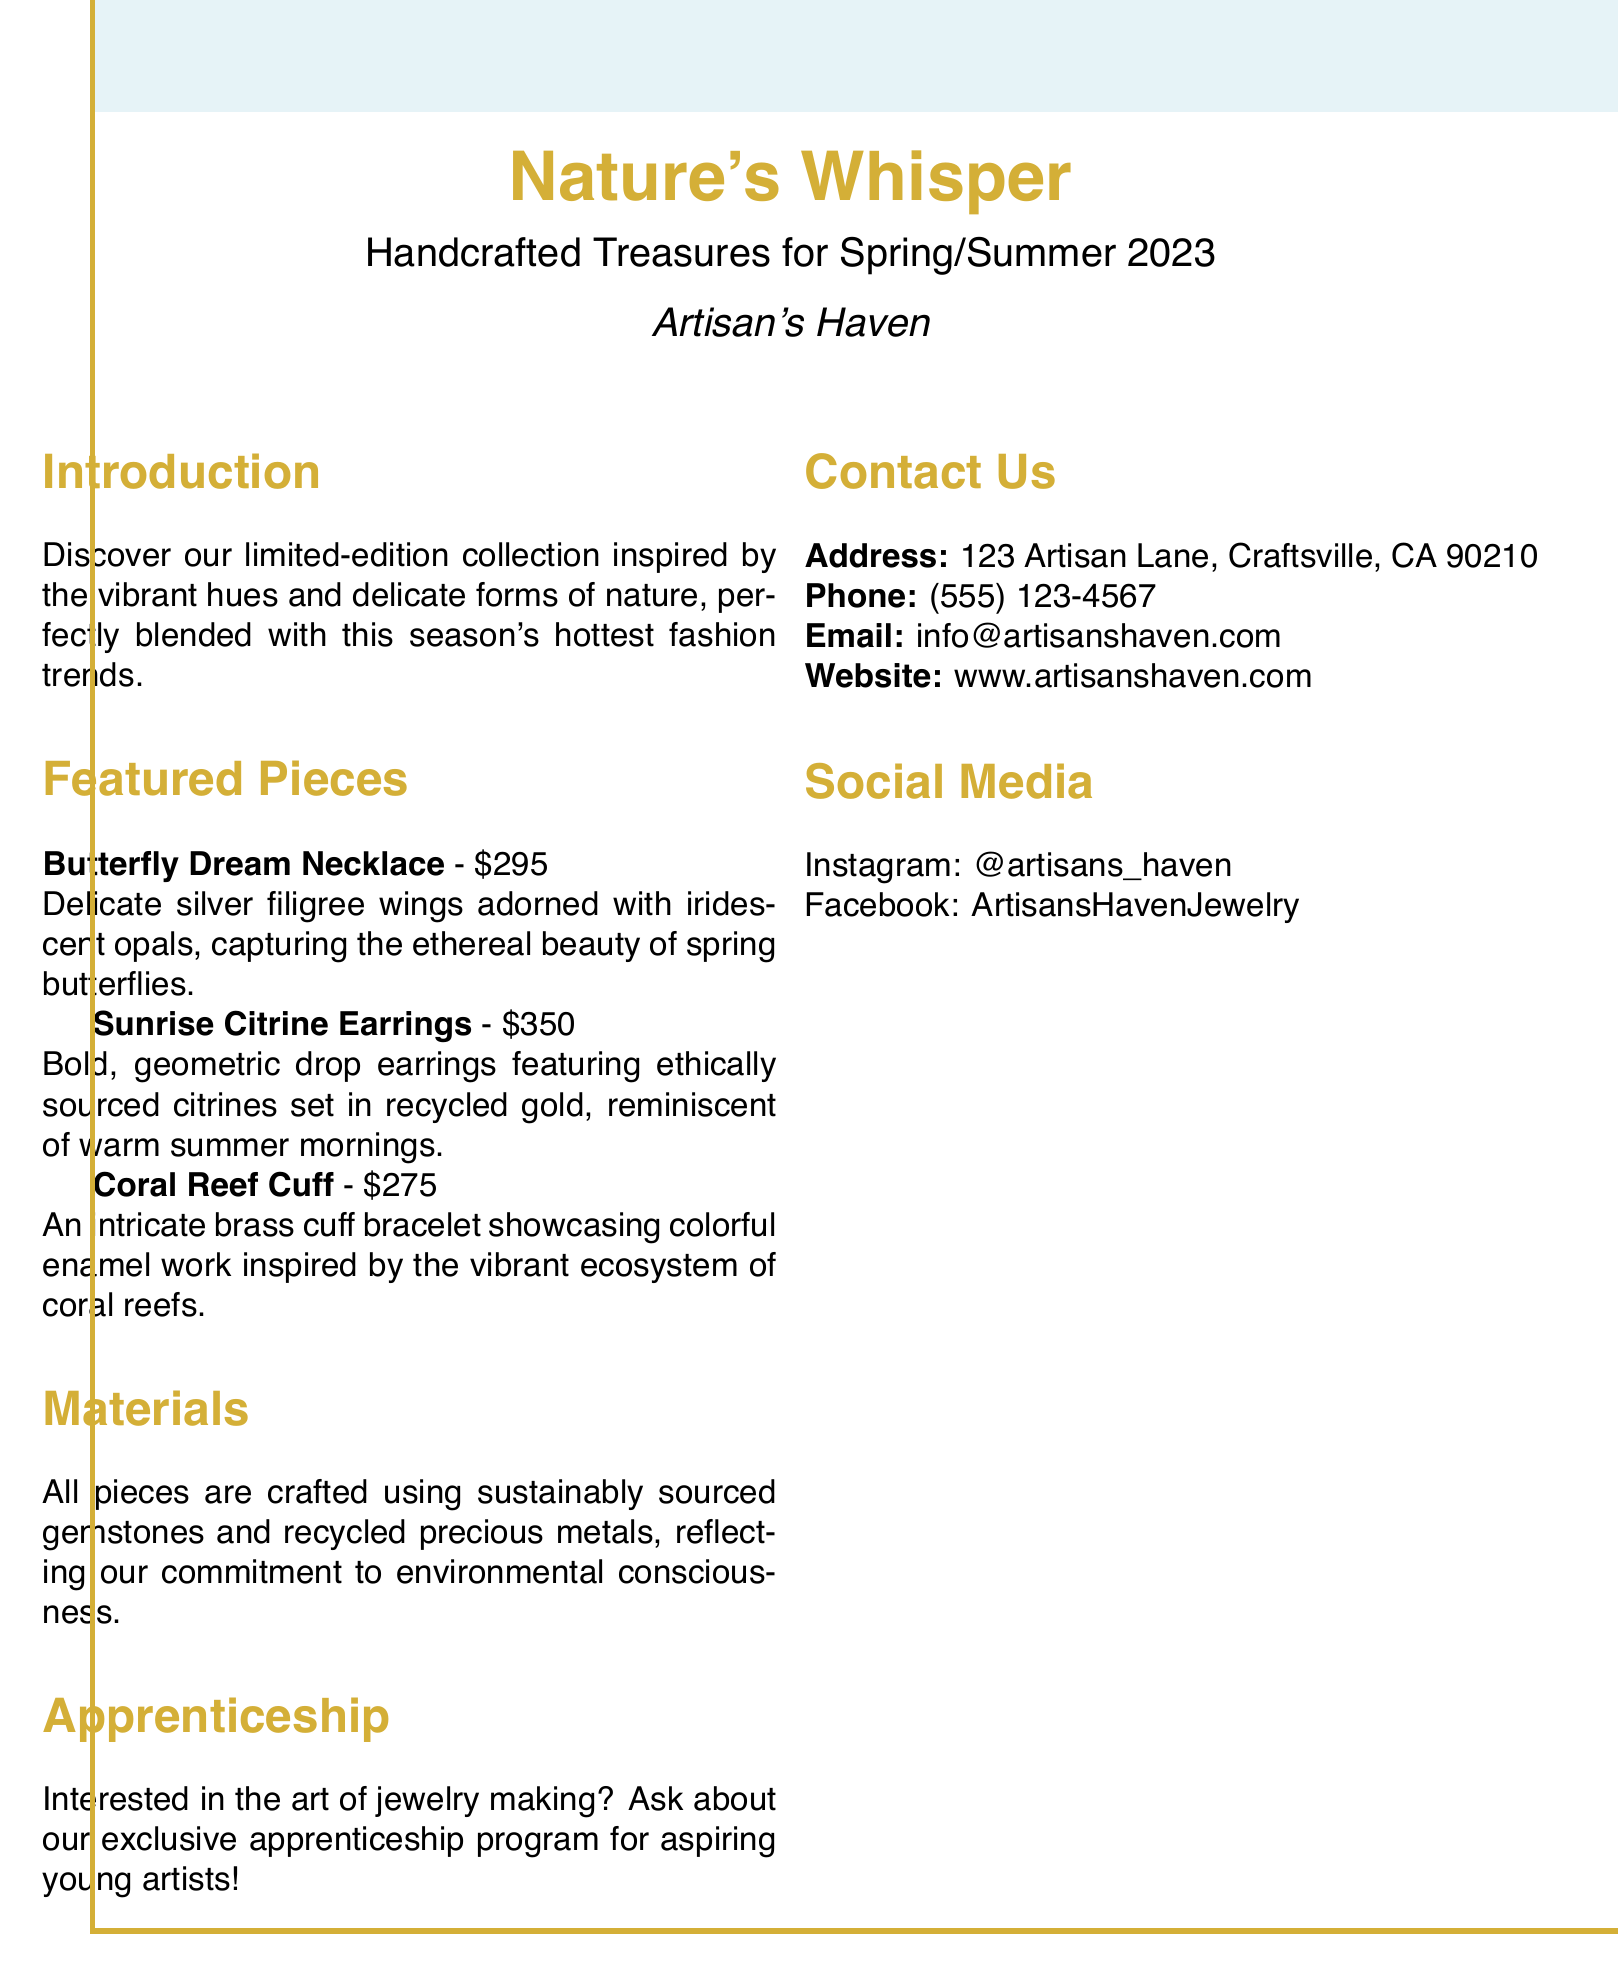What is the title of the catalog? The title of the catalog is stated at the top, indicating the collection name.
Answer: Nature's Whisper What is the price of the Coral Reef Cuff? The price is mentioned next to the item description in the featured pieces section.
Answer: $275 What gemstones are used in the Sunrise Citrine Earrings? The earrings are described with specific materials, indicating the primary gemstone used.
Answer: Citrines What is the address of Artisan's Haven? The address is listed in the contact information section of the document.
Answer: 123 Artisan Lane, Craftsville, CA 90210 What does the apprenticeship program offer? The document mentions the apprenticeship opportunity in relation to jewelry making, indicating its purpose.
Answer: Jewelry making How are the materials sourced for the jewelry pieces? The document explains the sourcing of materials, indicating their environmental commitment.
Answer: Sustainably sourced What seasonal collection is highlighted in this catalog? The introduction states the specific season for which the collection is made, reflecting its relevance.
Answer: Spring/Summer 2023 What type of earrings are featured in the catalog? The type of earrings is specified in the featured pieces section with a detailed description.
Answer: Drop earrings 